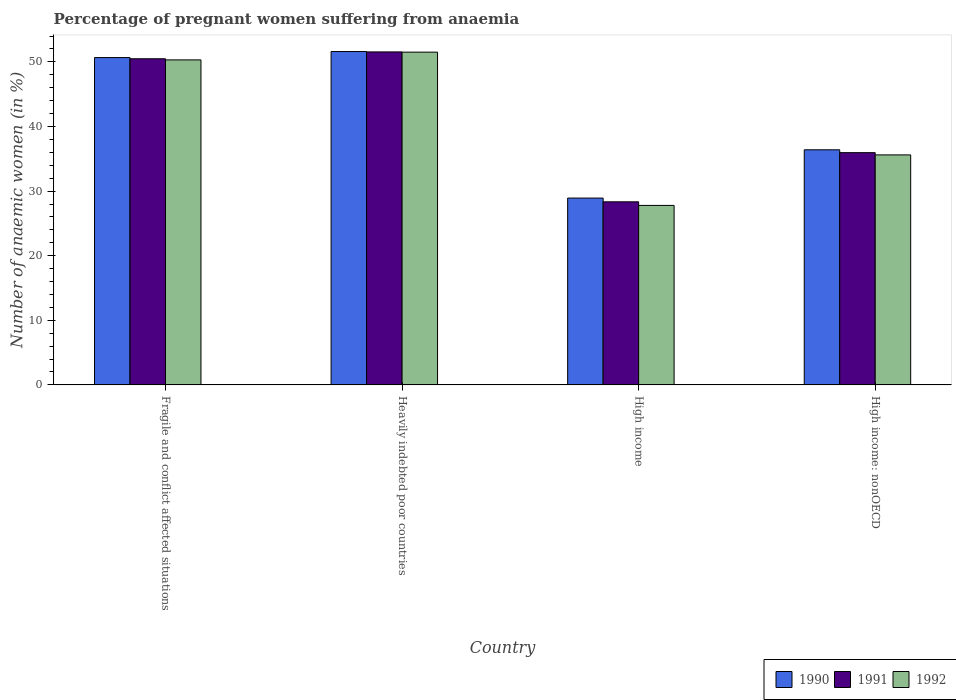How many different coloured bars are there?
Offer a terse response. 3. How many groups of bars are there?
Your answer should be compact. 4. Are the number of bars per tick equal to the number of legend labels?
Offer a very short reply. Yes. Are the number of bars on each tick of the X-axis equal?
Provide a short and direct response. Yes. What is the label of the 4th group of bars from the left?
Keep it short and to the point. High income: nonOECD. What is the number of anaemic women in 1990 in Fragile and conflict affected situations?
Give a very brief answer. 50.67. Across all countries, what is the maximum number of anaemic women in 1990?
Your answer should be very brief. 51.6. Across all countries, what is the minimum number of anaemic women in 1990?
Ensure brevity in your answer.  28.92. In which country was the number of anaemic women in 1990 maximum?
Offer a very short reply. Heavily indebted poor countries. What is the total number of anaemic women in 1991 in the graph?
Offer a terse response. 166.31. What is the difference between the number of anaemic women in 1992 in Fragile and conflict affected situations and that in Heavily indebted poor countries?
Provide a short and direct response. -1.2. What is the difference between the number of anaemic women in 1992 in Heavily indebted poor countries and the number of anaemic women in 1991 in Fragile and conflict affected situations?
Ensure brevity in your answer.  1.02. What is the average number of anaemic women in 1992 per country?
Your answer should be compact. 41.3. What is the difference between the number of anaemic women of/in 1990 and number of anaemic women of/in 1991 in Heavily indebted poor countries?
Your answer should be compact. 0.06. What is the ratio of the number of anaemic women in 1991 in Fragile and conflict affected situations to that in Heavily indebted poor countries?
Your answer should be compact. 0.98. Is the number of anaemic women in 1992 in High income less than that in High income: nonOECD?
Offer a very short reply. Yes. What is the difference between the highest and the second highest number of anaemic women in 1991?
Make the answer very short. -14.53. What is the difference between the highest and the lowest number of anaemic women in 1990?
Ensure brevity in your answer.  22.68. Is the sum of the number of anaemic women in 1991 in Heavily indebted poor countries and High income greater than the maximum number of anaemic women in 1992 across all countries?
Your answer should be compact. Yes. What does the 3rd bar from the left in Fragile and conflict affected situations represents?
Offer a very short reply. 1992. How many bars are there?
Provide a short and direct response. 12. Are all the bars in the graph horizontal?
Your answer should be compact. No. How many countries are there in the graph?
Give a very brief answer. 4. Are the values on the major ticks of Y-axis written in scientific E-notation?
Provide a short and direct response. No. Where does the legend appear in the graph?
Keep it short and to the point. Bottom right. How are the legend labels stacked?
Provide a short and direct response. Horizontal. What is the title of the graph?
Your answer should be very brief. Percentage of pregnant women suffering from anaemia. What is the label or title of the X-axis?
Keep it short and to the point. Country. What is the label or title of the Y-axis?
Ensure brevity in your answer.  Number of anaemic women (in %). What is the Number of anaemic women (in %) of 1990 in Fragile and conflict affected situations?
Make the answer very short. 50.67. What is the Number of anaemic women (in %) of 1991 in Fragile and conflict affected situations?
Keep it short and to the point. 50.48. What is the Number of anaemic women (in %) of 1992 in Fragile and conflict affected situations?
Give a very brief answer. 50.31. What is the Number of anaemic women (in %) of 1990 in Heavily indebted poor countries?
Ensure brevity in your answer.  51.6. What is the Number of anaemic women (in %) in 1991 in Heavily indebted poor countries?
Keep it short and to the point. 51.54. What is the Number of anaemic women (in %) of 1992 in Heavily indebted poor countries?
Your answer should be very brief. 51.51. What is the Number of anaemic women (in %) in 1990 in High income?
Give a very brief answer. 28.92. What is the Number of anaemic women (in %) of 1991 in High income?
Offer a very short reply. 28.34. What is the Number of anaemic women (in %) in 1992 in High income?
Offer a very short reply. 27.78. What is the Number of anaemic women (in %) of 1990 in High income: nonOECD?
Make the answer very short. 36.39. What is the Number of anaemic women (in %) of 1991 in High income: nonOECD?
Provide a short and direct response. 35.95. What is the Number of anaemic women (in %) in 1992 in High income: nonOECD?
Provide a succinct answer. 35.6. Across all countries, what is the maximum Number of anaemic women (in %) of 1990?
Your answer should be compact. 51.6. Across all countries, what is the maximum Number of anaemic women (in %) of 1991?
Make the answer very short. 51.54. Across all countries, what is the maximum Number of anaemic women (in %) in 1992?
Give a very brief answer. 51.51. Across all countries, what is the minimum Number of anaemic women (in %) in 1990?
Offer a terse response. 28.92. Across all countries, what is the minimum Number of anaemic women (in %) of 1991?
Offer a very short reply. 28.34. Across all countries, what is the minimum Number of anaemic women (in %) in 1992?
Your response must be concise. 27.78. What is the total Number of anaemic women (in %) in 1990 in the graph?
Provide a short and direct response. 167.57. What is the total Number of anaemic women (in %) of 1991 in the graph?
Your response must be concise. 166.31. What is the total Number of anaemic women (in %) in 1992 in the graph?
Ensure brevity in your answer.  165.2. What is the difference between the Number of anaemic women (in %) in 1990 in Fragile and conflict affected situations and that in Heavily indebted poor countries?
Provide a short and direct response. -0.93. What is the difference between the Number of anaemic women (in %) in 1991 in Fragile and conflict affected situations and that in Heavily indebted poor countries?
Provide a short and direct response. -1.06. What is the difference between the Number of anaemic women (in %) in 1990 in Fragile and conflict affected situations and that in High income?
Ensure brevity in your answer.  21.75. What is the difference between the Number of anaemic women (in %) in 1991 in Fragile and conflict affected situations and that in High income?
Provide a short and direct response. 22.14. What is the difference between the Number of anaemic women (in %) of 1992 in Fragile and conflict affected situations and that in High income?
Keep it short and to the point. 22.52. What is the difference between the Number of anaemic women (in %) of 1990 in Fragile and conflict affected situations and that in High income: nonOECD?
Your answer should be very brief. 14.28. What is the difference between the Number of anaemic women (in %) of 1991 in Fragile and conflict affected situations and that in High income: nonOECD?
Your answer should be very brief. 14.53. What is the difference between the Number of anaemic women (in %) in 1992 in Fragile and conflict affected situations and that in High income: nonOECD?
Give a very brief answer. 14.7. What is the difference between the Number of anaemic women (in %) of 1990 in Heavily indebted poor countries and that in High income?
Make the answer very short. 22.68. What is the difference between the Number of anaemic women (in %) of 1991 in Heavily indebted poor countries and that in High income?
Ensure brevity in your answer.  23.2. What is the difference between the Number of anaemic women (in %) of 1992 in Heavily indebted poor countries and that in High income?
Offer a terse response. 23.72. What is the difference between the Number of anaemic women (in %) in 1990 in Heavily indebted poor countries and that in High income: nonOECD?
Offer a terse response. 15.21. What is the difference between the Number of anaemic women (in %) of 1991 in Heavily indebted poor countries and that in High income: nonOECD?
Your answer should be compact. 15.59. What is the difference between the Number of anaemic women (in %) in 1992 in Heavily indebted poor countries and that in High income: nonOECD?
Offer a very short reply. 15.9. What is the difference between the Number of anaemic women (in %) in 1990 in High income and that in High income: nonOECD?
Your answer should be very brief. -7.47. What is the difference between the Number of anaemic women (in %) of 1991 in High income and that in High income: nonOECD?
Provide a short and direct response. -7.61. What is the difference between the Number of anaemic women (in %) of 1992 in High income and that in High income: nonOECD?
Your answer should be very brief. -7.82. What is the difference between the Number of anaemic women (in %) in 1990 in Fragile and conflict affected situations and the Number of anaemic women (in %) in 1991 in Heavily indebted poor countries?
Ensure brevity in your answer.  -0.87. What is the difference between the Number of anaemic women (in %) of 1990 in Fragile and conflict affected situations and the Number of anaemic women (in %) of 1992 in Heavily indebted poor countries?
Provide a short and direct response. -0.84. What is the difference between the Number of anaemic women (in %) of 1991 in Fragile and conflict affected situations and the Number of anaemic women (in %) of 1992 in Heavily indebted poor countries?
Keep it short and to the point. -1.02. What is the difference between the Number of anaemic women (in %) in 1990 in Fragile and conflict affected situations and the Number of anaemic women (in %) in 1991 in High income?
Offer a very short reply. 22.33. What is the difference between the Number of anaemic women (in %) of 1990 in Fragile and conflict affected situations and the Number of anaemic women (in %) of 1992 in High income?
Ensure brevity in your answer.  22.88. What is the difference between the Number of anaemic women (in %) of 1991 in Fragile and conflict affected situations and the Number of anaemic women (in %) of 1992 in High income?
Offer a terse response. 22.7. What is the difference between the Number of anaemic women (in %) in 1990 in Fragile and conflict affected situations and the Number of anaemic women (in %) in 1991 in High income: nonOECD?
Provide a short and direct response. 14.72. What is the difference between the Number of anaemic women (in %) in 1990 in Fragile and conflict affected situations and the Number of anaemic women (in %) in 1992 in High income: nonOECD?
Offer a very short reply. 15.07. What is the difference between the Number of anaemic women (in %) of 1991 in Fragile and conflict affected situations and the Number of anaemic women (in %) of 1992 in High income: nonOECD?
Ensure brevity in your answer.  14.88. What is the difference between the Number of anaemic women (in %) of 1990 in Heavily indebted poor countries and the Number of anaemic women (in %) of 1991 in High income?
Your answer should be compact. 23.26. What is the difference between the Number of anaemic women (in %) in 1990 in Heavily indebted poor countries and the Number of anaemic women (in %) in 1992 in High income?
Provide a succinct answer. 23.82. What is the difference between the Number of anaemic women (in %) of 1991 in Heavily indebted poor countries and the Number of anaemic women (in %) of 1992 in High income?
Your answer should be very brief. 23.76. What is the difference between the Number of anaemic women (in %) in 1990 in Heavily indebted poor countries and the Number of anaemic women (in %) in 1991 in High income: nonOECD?
Keep it short and to the point. 15.65. What is the difference between the Number of anaemic women (in %) of 1990 in Heavily indebted poor countries and the Number of anaemic women (in %) of 1992 in High income: nonOECD?
Your answer should be compact. 16. What is the difference between the Number of anaemic women (in %) of 1991 in Heavily indebted poor countries and the Number of anaemic women (in %) of 1992 in High income: nonOECD?
Give a very brief answer. 15.94. What is the difference between the Number of anaemic women (in %) in 1990 in High income and the Number of anaemic women (in %) in 1991 in High income: nonOECD?
Offer a terse response. -7.03. What is the difference between the Number of anaemic women (in %) of 1990 in High income and the Number of anaemic women (in %) of 1992 in High income: nonOECD?
Offer a terse response. -6.68. What is the difference between the Number of anaemic women (in %) in 1991 in High income and the Number of anaemic women (in %) in 1992 in High income: nonOECD?
Ensure brevity in your answer.  -7.26. What is the average Number of anaemic women (in %) in 1990 per country?
Keep it short and to the point. 41.89. What is the average Number of anaemic women (in %) of 1991 per country?
Give a very brief answer. 41.58. What is the average Number of anaemic women (in %) in 1992 per country?
Your answer should be compact. 41.3. What is the difference between the Number of anaemic women (in %) of 1990 and Number of anaemic women (in %) of 1991 in Fragile and conflict affected situations?
Provide a short and direct response. 0.19. What is the difference between the Number of anaemic women (in %) in 1990 and Number of anaemic women (in %) in 1992 in Fragile and conflict affected situations?
Ensure brevity in your answer.  0.36. What is the difference between the Number of anaemic women (in %) in 1991 and Number of anaemic women (in %) in 1992 in Fragile and conflict affected situations?
Keep it short and to the point. 0.18. What is the difference between the Number of anaemic women (in %) in 1990 and Number of anaemic women (in %) in 1991 in Heavily indebted poor countries?
Keep it short and to the point. 0.06. What is the difference between the Number of anaemic women (in %) in 1990 and Number of anaemic women (in %) in 1992 in Heavily indebted poor countries?
Ensure brevity in your answer.  0.09. What is the difference between the Number of anaemic women (in %) of 1991 and Number of anaemic women (in %) of 1992 in Heavily indebted poor countries?
Your answer should be compact. 0.04. What is the difference between the Number of anaemic women (in %) in 1990 and Number of anaemic women (in %) in 1991 in High income?
Ensure brevity in your answer.  0.58. What is the difference between the Number of anaemic women (in %) of 1990 and Number of anaemic women (in %) of 1992 in High income?
Make the answer very short. 1.14. What is the difference between the Number of anaemic women (in %) of 1991 and Number of anaemic women (in %) of 1992 in High income?
Your answer should be compact. 0.56. What is the difference between the Number of anaemic women (in %) of 1990 and Number of anaemic women (in %) of 1991 in High income: nonOECD?
Keep it short and to the point. 0.44. What is the difference between the Number of anaemic women (in %) in 1990 and Number of anaemic women (in %) in 1992 in High income: nonOECD?
Your answer should be very brief. 0.79. What is the difference between the Number of anaemic women (in %) in 1991 and Number of anaemic women (in %) in 1992 in High income: nonOECD?
Offer a very short reply. 0.35. What is the ratio of the Number of anaemic women (in %) of 1990 in Fragile and conflict affected situations to that in Heavily indebted poor countries?
Offer a terse response. 0.98. What is the ratio of the Number of anaemic women (in %) of 1991 in Fragile and conflict affected situations to that in Heavily indebted poor countries?
Offer a very short reply. 0.98. What is the ratio of the Number of anaemic women (in %) of 1992 in Fragile and conflict affected situations to that in Heavily indebted poor countries?
Provide a short and direct response. 0.98. What is the ratio of the Number of anaemic women (in %) in 1990 in Fragile and conflict affected situations to that in High income?
Provide a succinct answer. 1.75. What is the ratio of the Number of anaemic women (in %) of 1991 in Fragile and conflict affected situations to that in High income?
Your answer should be very brief. 1.78. What is the ratio of the Number of anaemic women (in %) of 1992 in Fragile and conflict affected situations to that in High income?
Give a very brief answer. 1.81. What is the ratio of the Number of anaemic women (in %) in 1990 in Fragile and conflict affected situations to that in High income: nonOECD?
Give a very brief answer. 1.39. What is the ratio of the Number of anaemic women (in %) of 1991 in Fragile and conflict affected situations to that in High income: nonOECD?
Keep it short and to the point. 1.4. What is the ratio of the Number of anaemic women (in %) of 1992 in Fragile and conflict affected situations to that in High income: nonOECD?
Provide a short and direct response. 1.41. What is the ratio of the Number of anaemic women (in %) of 1990 in Heavily indebted poor countries to that in High income?
Offer a very short reply. 1.78. What is the ratio of the Number of anaemic women (in %) in 1991 in Heavily indebted poor countries to that in High income?
Offer a very short reply. 1.82. What is the ratio of the Number of anaemic women (in %) in 1992 in Heavily indebted poor countries to that in High income?
Your answer should be compact. 1.85. What is the ratio of the Number of anaemic women (in %) in 1990 in Heavily indebted poor countries to that in High income: nonOECD?
Offer a terse response. 1.42. What is the ratio of the Number of anaemic women (in %) in 1991 in Heavily indebted poor countries to that in High income: nonOECD?
Give a very brief answer. 1.43. What is the ratio of the Number of anaemic women (in %) of 1992 in Heavily indebted poor countries to that in High income: nonOECD?
Offer a terse response. 1.45. What is the ratio of the Number of anaemic women (in %) in 1990 in High income to that in High income: nonOECD?
Your answer should be very brief. 0.79. What is the ratio of the Number of anaemic women (in %) of 1991 in High income to that in High income: nonOECD?
Ensure brevity in your answer.  0.79. What is the ratio of the Number of anaemic women (in %) of 1992 in High income to that in High income: nonOECD?
Give a very brief answer. 0.78. What is the difference between the highest and the second highest Number of anaemic women (in %) of 1990?
Provide a succinct answer. 0.93. What is the difference between the highest and the second highest Number of anaemic women (in %) in 1991?
Offer a very short reply. 1.06. What is the difference between the highest and the lowest Number of anaemic women (in %) of 1990?
Provide a succinct answer. 22.68. What is the difference between the highest and the lowest Number of anaemic women (in %) of 1991?
Your answer should be very brief. 23.2. What is the difference between the highest and the lowest Number of anaemic women (in %) of 1992?
Keep it short and to the point. 23.72. 